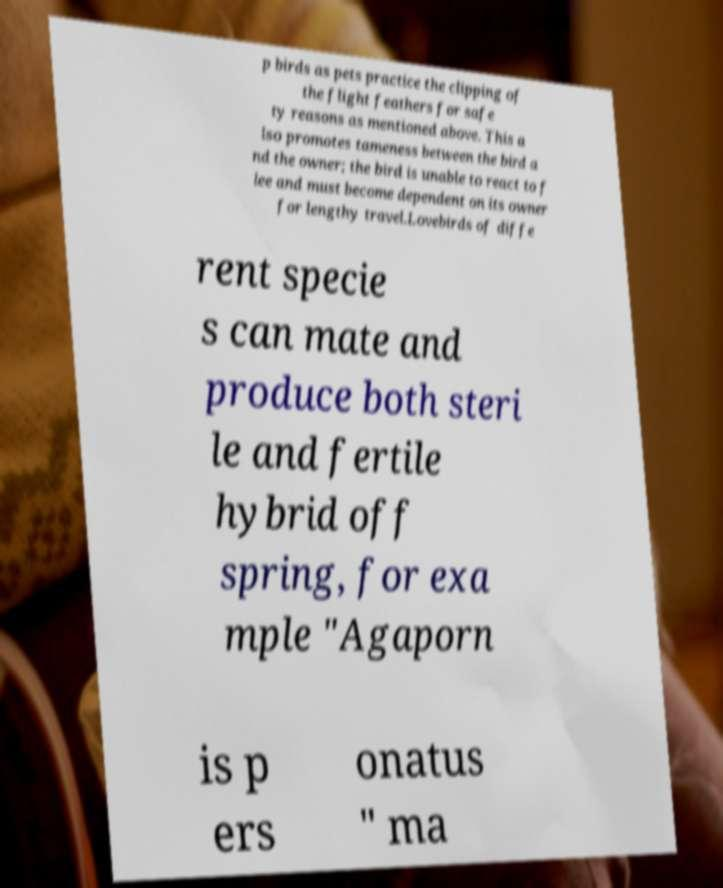Can you read and provide the text displayed in the image?This photo seems to have some interesting text. Can you extract and type it out for me? p birds as pets practice the clipping of the flight feathers for safe ty reasons as mentioned above. This a lso promotes tameness between the bird a nd the owner; the bird is unable to react to f lee and must become dependent on its owner for lengthy travel.Lovebirds of diffe rent specie s can mate and produce both steri le and fertile hybrid off spring, for exa mple "Agaporn is p ers onatus " ma 